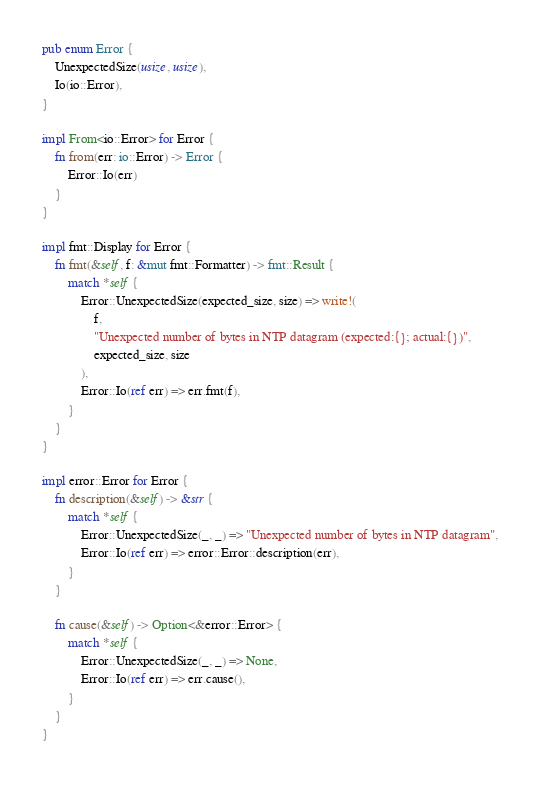<code> <loc_0><loc_0><loc_500><loc_500><_Rust_>pub enum Error {
    UnexpectedSize(usize, usize),
    Io(io::Error),
}

impl From<io::Error> for Error {
    fn from(err: io::Error) -> Error {
        Error::Io(err)
    }
}

impl fmt::Display for Error {
    fn fmt(&self, f: &mut fmt::Formatter) -> fmt::Result {
        match *self {
            Error::UnexpectedSize(expected_size, size) => write!(
                f,
                "Unexpected number of bytes in NTP datagram (expected:{}; actual:{})",
                expected_size, size
            ),
            Error::Io(ref err) => err.fmt(f),
        }
    }
}

impl error::Error for Error {
    fn description(&self) -> &str {
        match *self {
            Error::UnexpectedSize(_, _) => "Unexpected number of bytes in NTP datagram",
            Error::Io(ref err) => error::Error::description(err),
        }
    }

    fn cause(&self) -> Option<&error::Error> {
        match *self {
            Error::UnexpectedSize(_, _) => None,
            Error::Io(ref err) => err.cause(),
        }
    }
}
</code> 